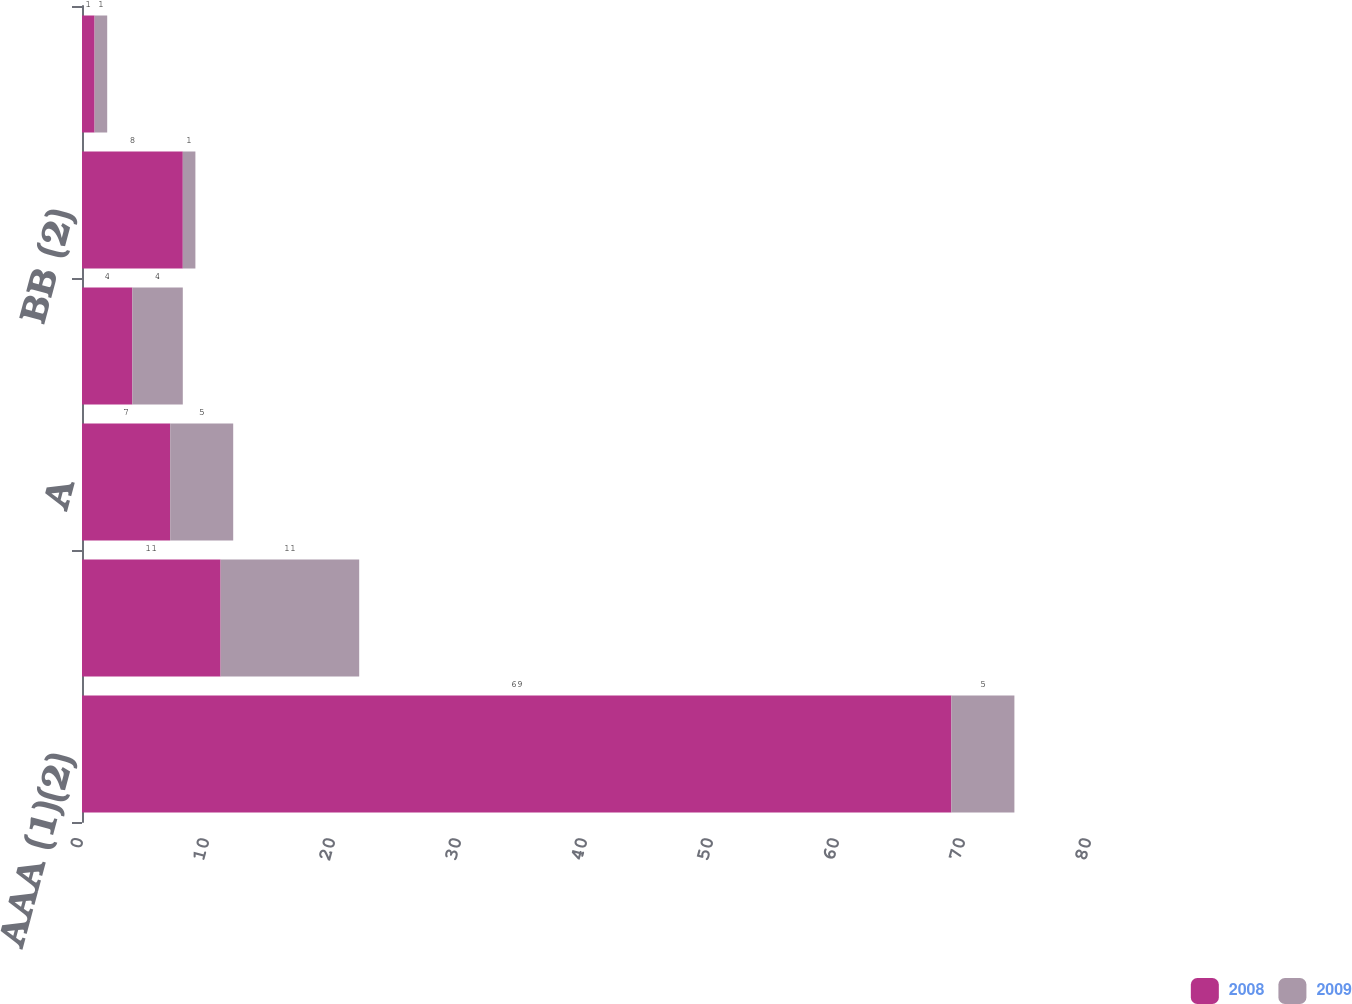Convert chart to OTSL. <chart><loc_0><loc_0><loc_500><loc_500><stacked_bar_chart><ecel><fcel>AAA (1)(2)<fcel>AA<fcel>A<fcel>BBB<fcel>BB (2)<fcel>Non-rated<nl><fcel>2008<fcel>69<fcel>11<fcel>7<fcel>4<fcel>8<fcel>1<nl><fcel>2009<fcel>5<fcel>11<fcel>5<fcel>4<fcel>1<fcel>1<nl></chart> 